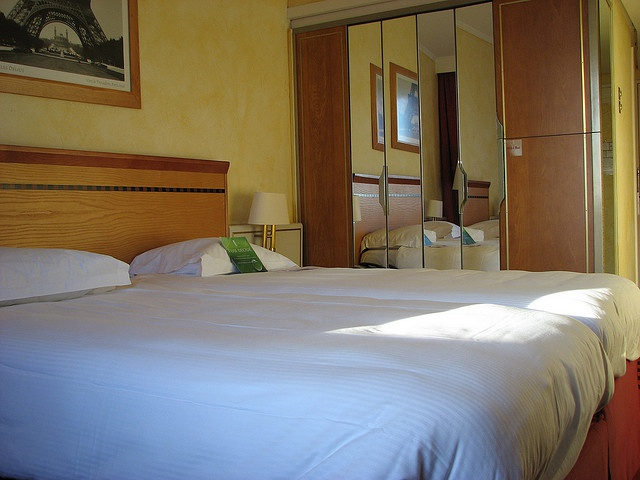Describe the objects in this image and their specific colors. I can see bed in gray, darkgray, and lightblue tones and bed in gray and olive tones in this image. 